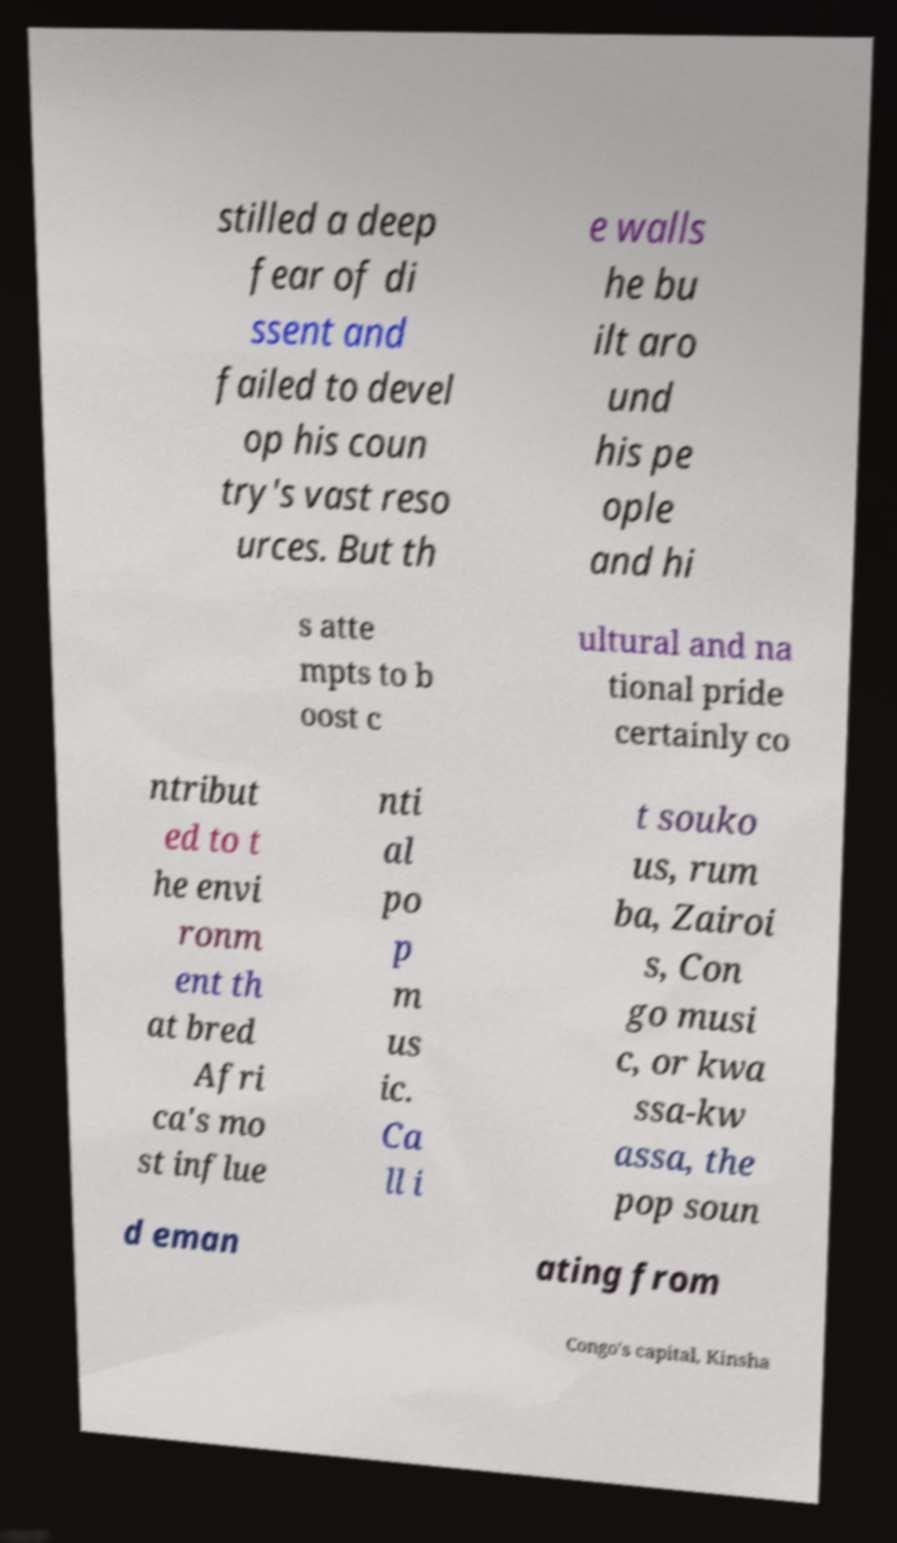Can you read and provide the text displayed in the image?This photo seems to have some interesting text. Can you extract and type it out for me? stilled a deep fear of di ssent and failed to devel op his coun try's vast reso urces. But th e walls he bu ilt aro und his pe ople and hi s atte mpts to b oost c ultural and na tional pride certainly co ntribut ed to t he envi ronm ent th at bred Afri ca's mo st influe nti al po p m us ic. Ca ll i t souko us, rum ba, Zairoi s, Con go musi c, or kwa ssa-kw assa, the pop soun d eman ating from Congo's capital, Kinsha 